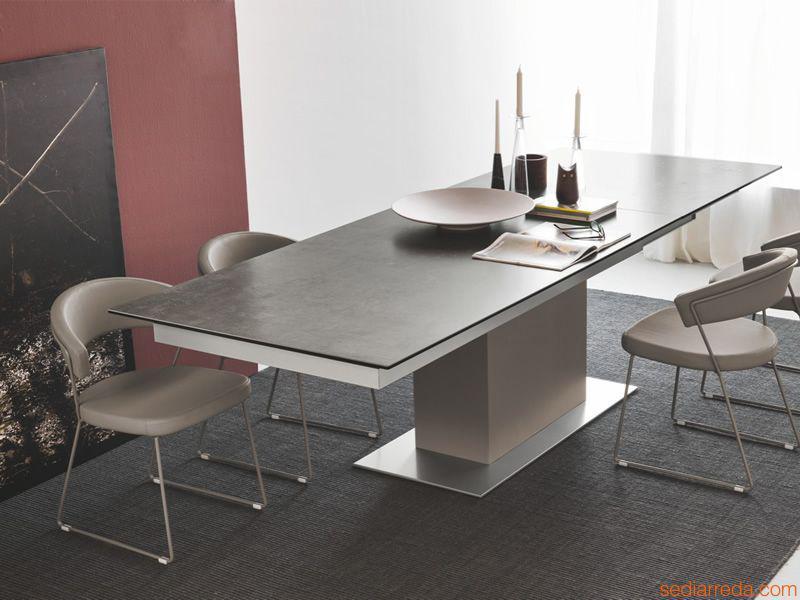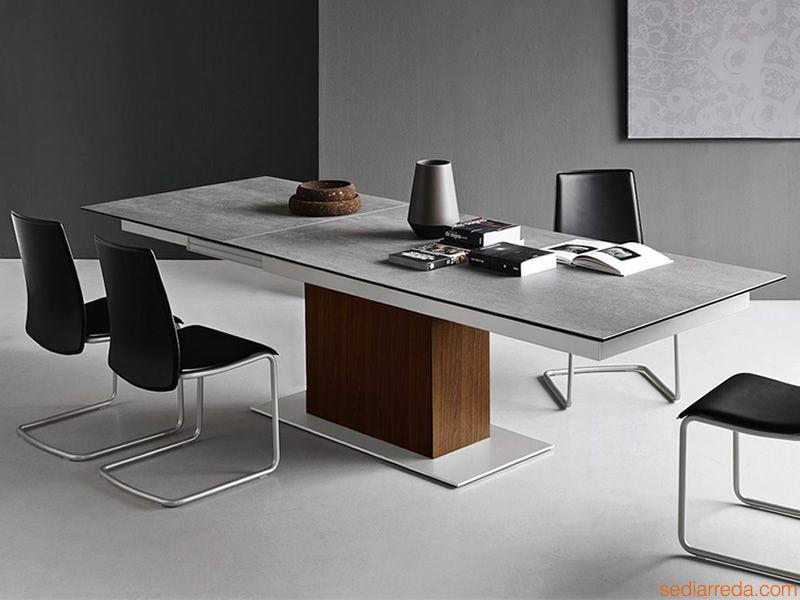The first image is the image on the left, the second image is the image on the right. Examine the images to the left and right. Is the description "The legs on the table in one of the images is shaped like the letter """"x""""." accurate? Answer yes or no. No. The first image is the image on the left, the second image is the image on the right. Considering the images on both sides, is "One image shows two white chairs with criss-crossed backs at a light wood table with X-shaped legs, and the other image shows a dark-topped rectangular table with a rectangular pedestal base." valid? Answer yes or no. No. 